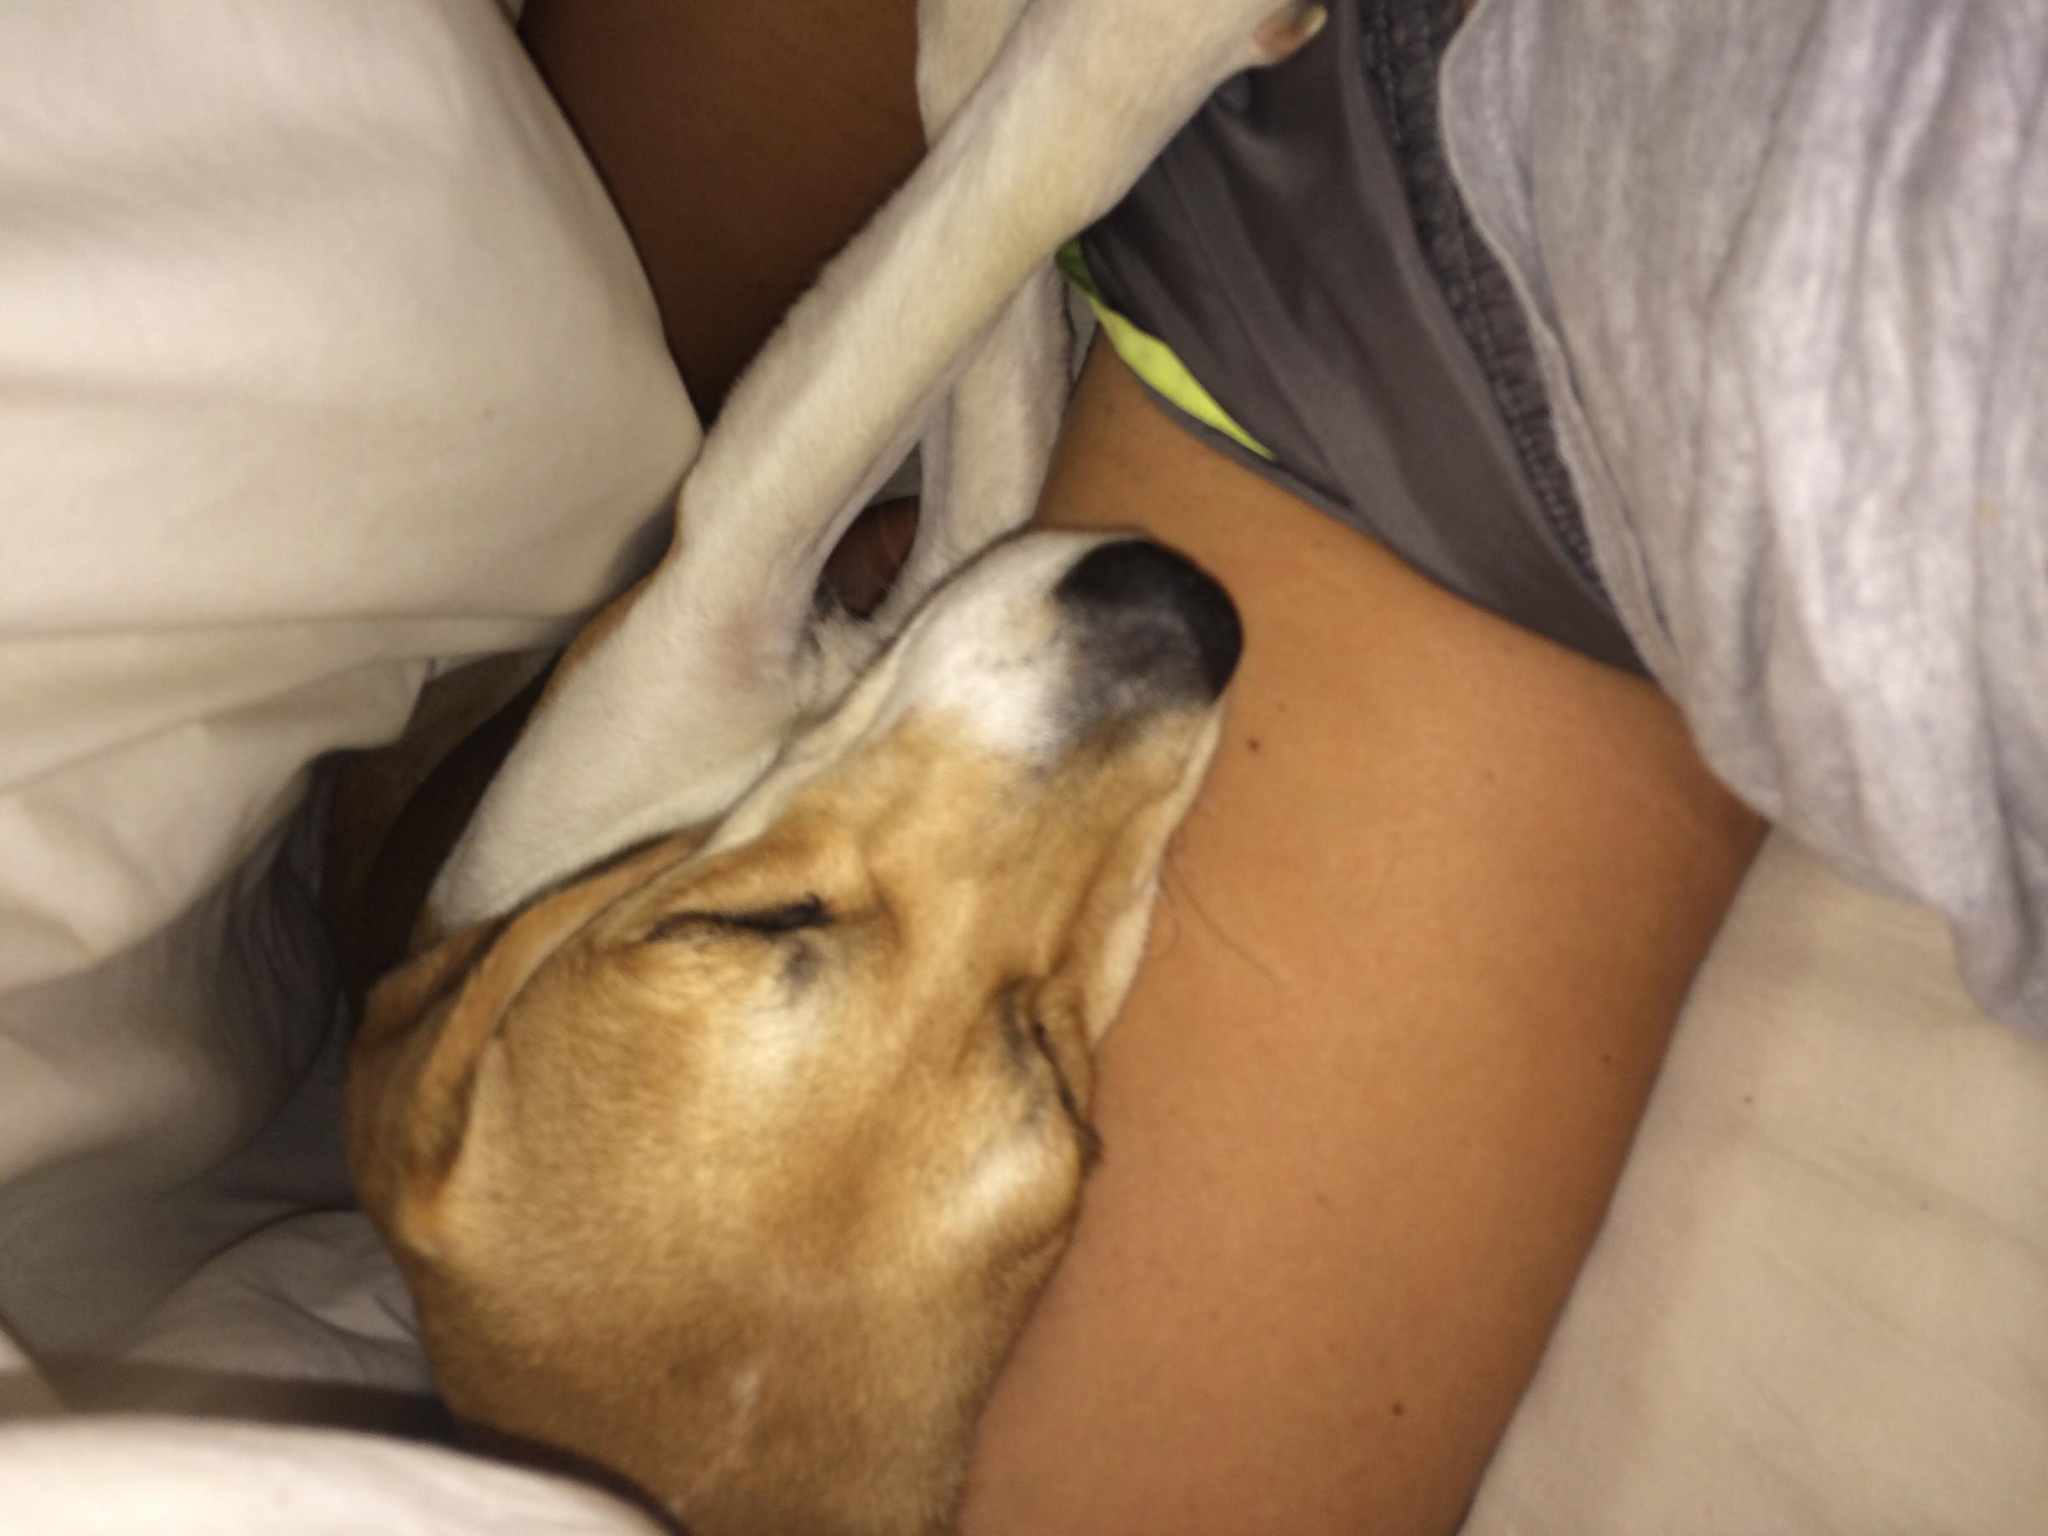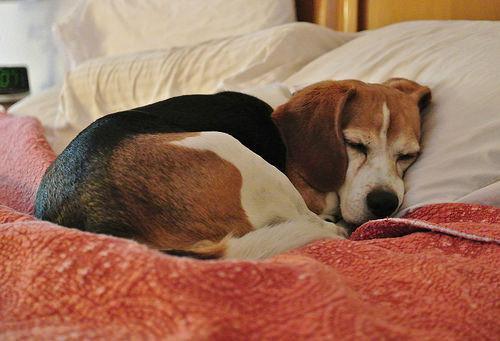The first image is the image on the left, the second image is the image on the right. Evaluate the accuracy of this statement regarding the images: "There is a one beagle in each picture, all sound asleep.". Is it true? Answer yes or no. Yes. The first image is the image on the left, the second image is the image on the right. Evaluate the accuracy of this statement regarding the images: "A dog is sleeping on a couch (sofa).". Is it true? Answer yes or no. No. 